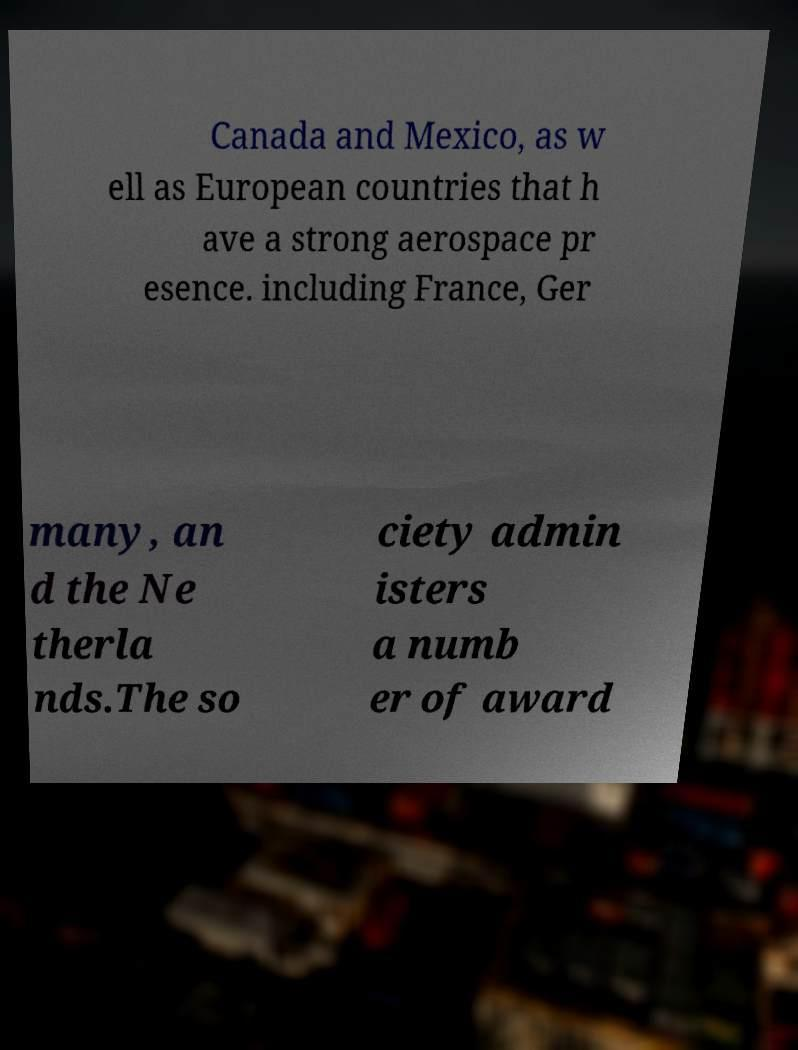There's text embedded in this image that I need extracted. Can you transcribe it verbatim? Canada and Mexico, as w ell as European countries that h ave a strong aerospace pr esence. including France, Ger many, an d the Ne therla nds.The so ciety admin isters a numb er of award 